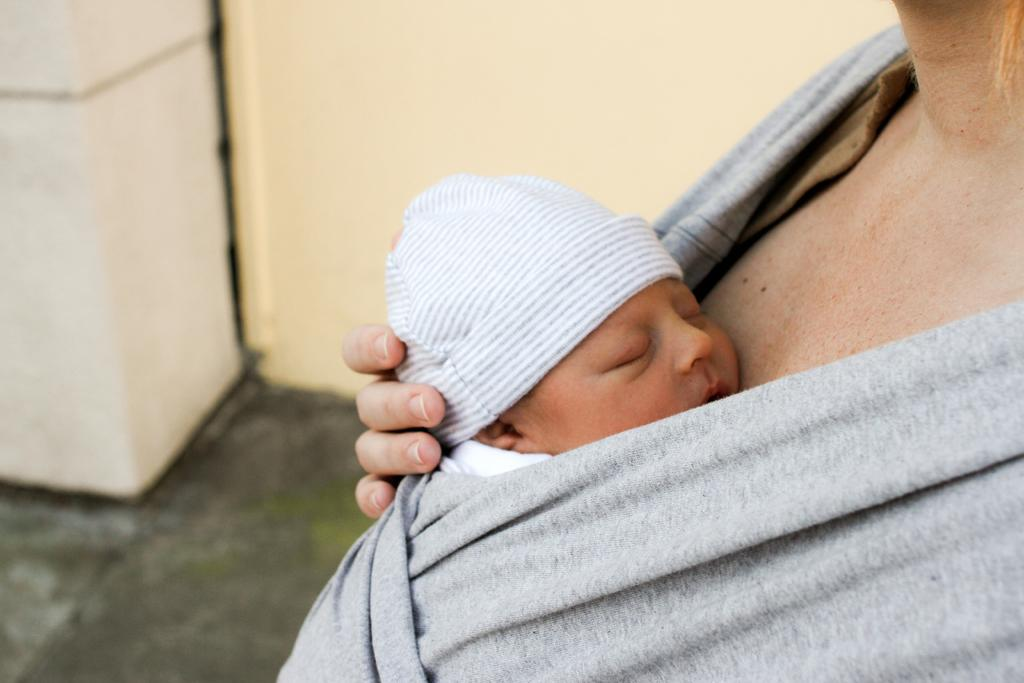Who is the main subject in the image? There is a woman in the image. What is the woman holding in the image? The woman is holding a small baby. What can be seen in the background of the image? There is a wall in the background of the image. What part of the room or setting is visible in the image? The floor is visible in the image. What type of whip can be seen in the woman's hand in the image? There is no whip present in the woman's hand or in the image. Can you tell me how many limits are visible in the image? There are no limits present in the image; the term "limit" does not apply to the content of the image. 